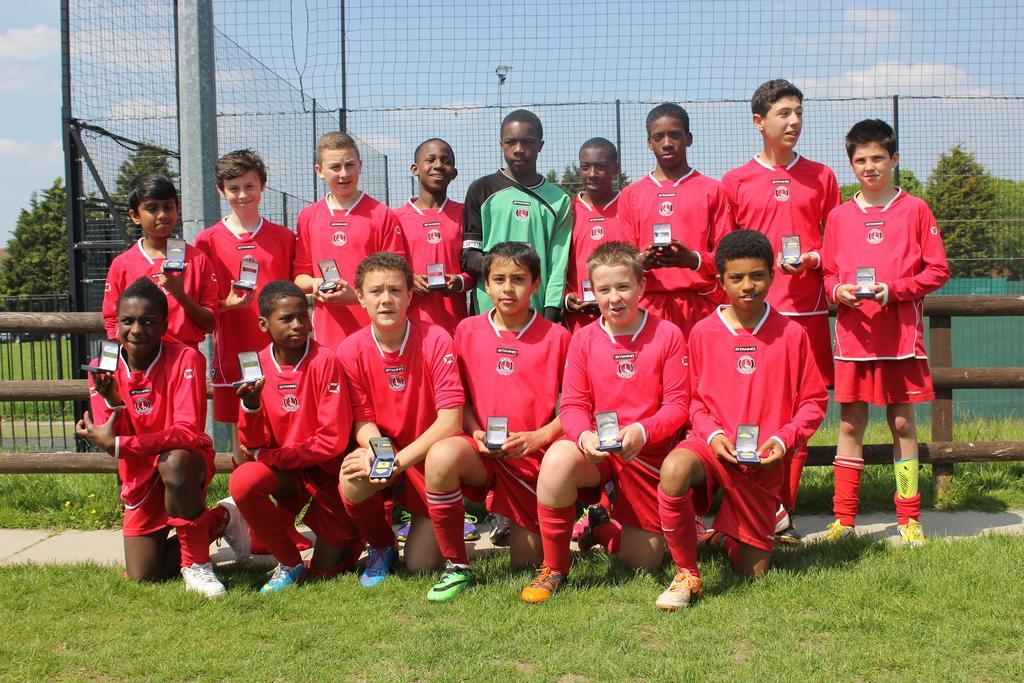How would you summarize this image in a sentence or two? In this image, we can see some trees and grass. There are some kids in the middle of the image wearing clothes and holding objects with their hands. There are poles in the top left of the image. There is a mesh at the top of the image. 